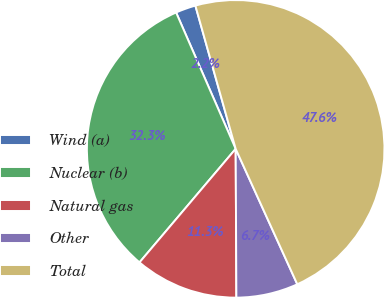Convert chart to OTSL. <chart><loc_0><loc_0><loc_500><loc_500><pie_chart><fcel>Wind (a)<fcel>Nuclear (b)<fcel>Natural gas<fcel>Other<fcel>Total<nl><fcel>2.19%<fcel>32.26%<fcel>11.26%<fcel>6.72%<fcel>47.57%<nl></chart> 